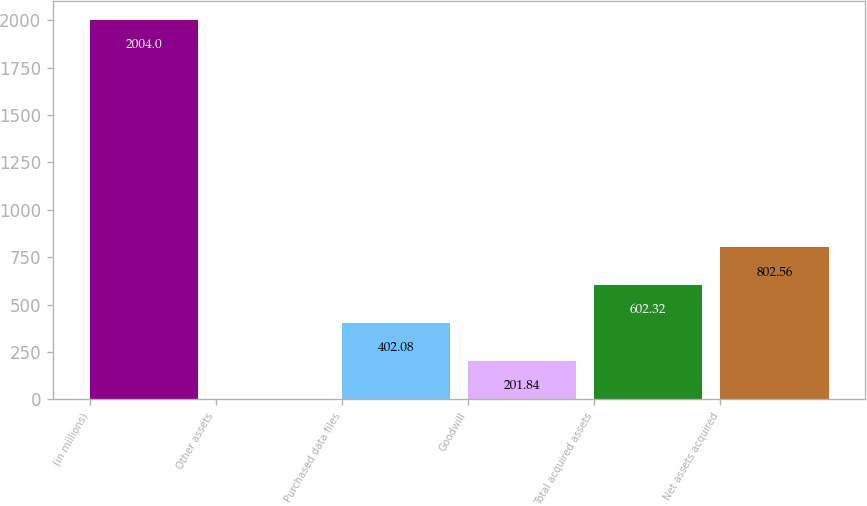<chart> <loc_0><loc_0><loc_500><loc_500><bar_chart><fcel>(in millions)<fcel>Other assets<fcel>Purchased data files<fcel>Goodwill<fcel>Total acquired assets<fcel>Net assets acquired<nl><fcel>2004<fcel>1.6<fcel>402.08<fcel>201.84<fcel>602.32<fcel>802.56<nl></chart> 